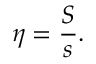Convert formula to latex. <formula><loc_0><loc_0><loc_500><loc_500>\eta = { \frac { S } { s } } .</formula> 